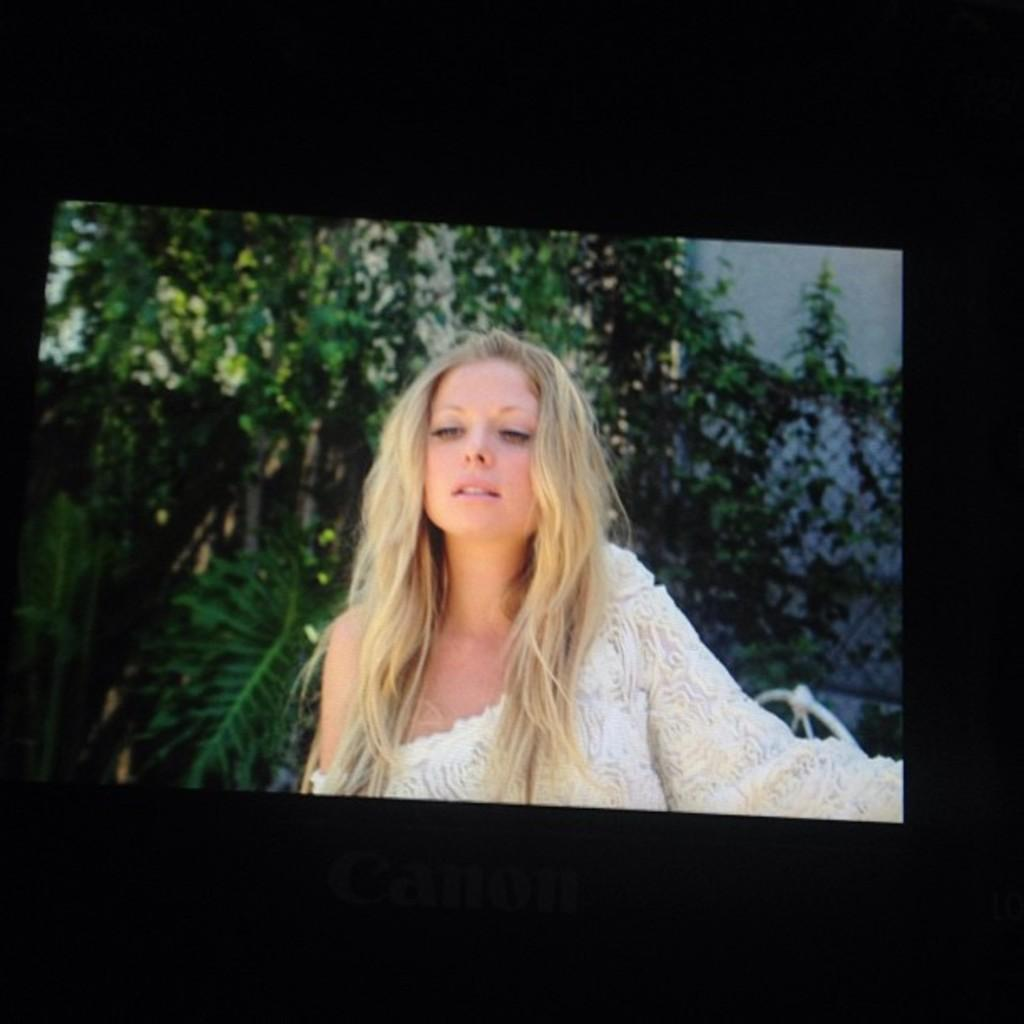What is displayed on the camera screen in the image? There is a picture of a woman on the camera screen. What else can be seen on the camera screen? There are trees visible on the camera screen. What type of scissors is the woman using to beginner her watch in the image? There is no woman using scissors to beginner her watch in the image; it only shows a picture of a woman on the camera screen. 